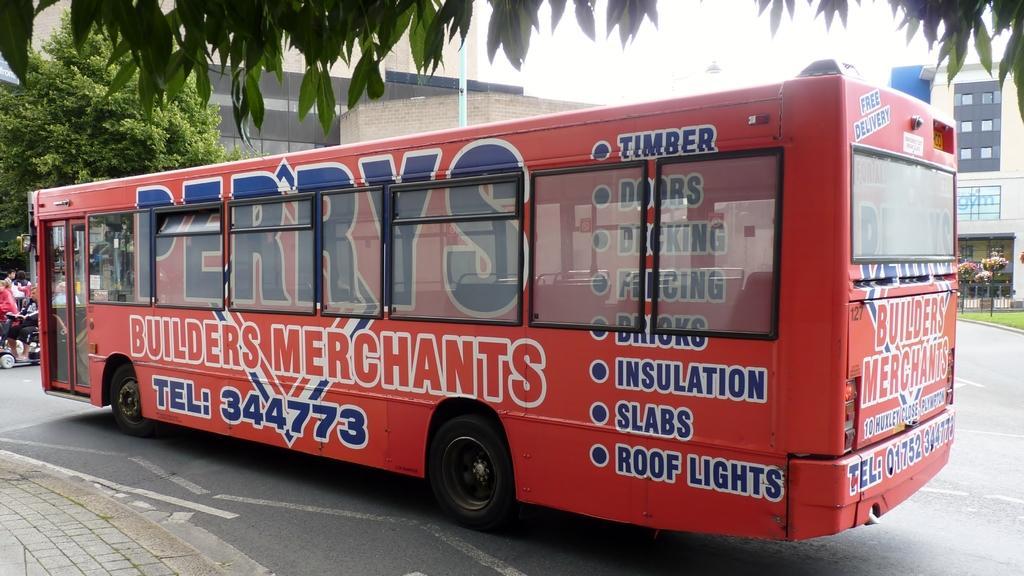How would you summarize this image in a sentence or two? In this picture we can see a bus and some people on the road, trees and in the background we can see buildings with windows. 